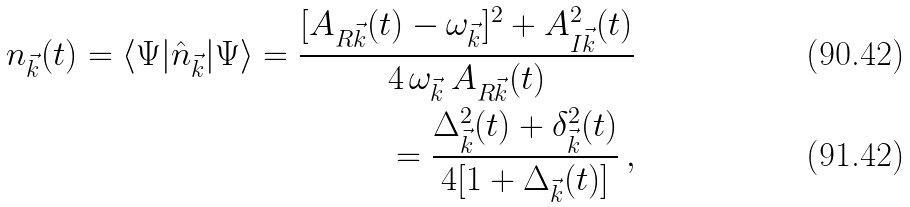Convert formula to latex. <formula><loc_0><loc_0><loc_500><loc_500>n _ { \vec { k } } ( t ) = \langle \Psi | \hat { n } _ { \vec { k } } | \Psi \rangle = \frac { [ A _ { R { \vec { k } } } ( t ) - \omega _ { \vec { k } } ] ^ { 2 } + A _ { I { \vec { k } } } ^ { 2 } ( t ) } { 4 \, \omega _ { \vec { k } } \, A _ { R { \vec { k } } } ( t ) } \\ = \frac { \Delta _ { \vec { k } } ^ { 2 } ( t ) + \delta _ { \vec { k } } ^ { 2 } ( t ) } { 4 [ 1 + \Delta _ { \vec { k } } ( t ) ] } \, ,</formula> 